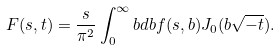<formula> <loc_0><loc_0><loc_500><loc_500>F ( s , t ) = \frac { s } { \pi ^ { 2 } } \int _ { 0 } ^ { \infty } b d b f ( s , b ) J _ { 0 } ( b \sqrt { - t } ) .</formula> 